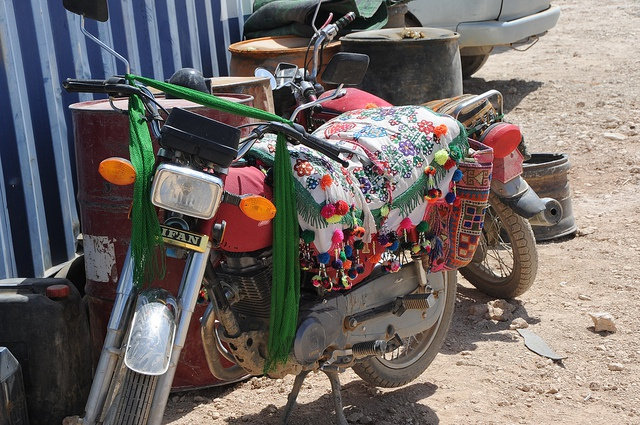Describe the objects in this image and their specific colors. I can see motorcycle in darkgray, black, gray, and maroon tones, motorcycle in darkgray, black, gray, and maroon tones, and car in darkgray, gray, and black tones in this image. 